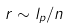<formula> <loc_0><loc_0><loc_500><loc_500>r \sim l _ { p } / n</formula> 